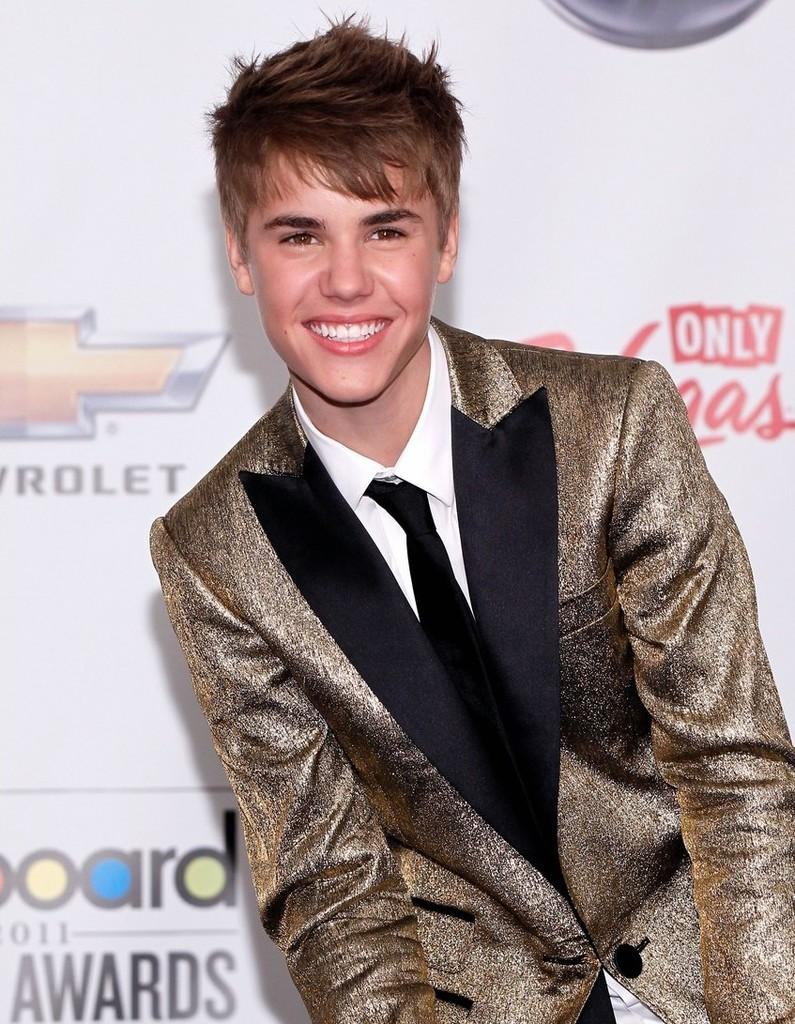Who is the main subject in the foreground of the image? There is a man in the foreground of the image. What is the man doing in the image? The man is smiling. What can be seen in the background of the image? There is a board in the background of the image. What is written on the board? There is text visible on the board. What type of pies are being served at the event in the image? There is no event or pies present in the image; it features a man smiling in the foreground and a board with text in the background. 